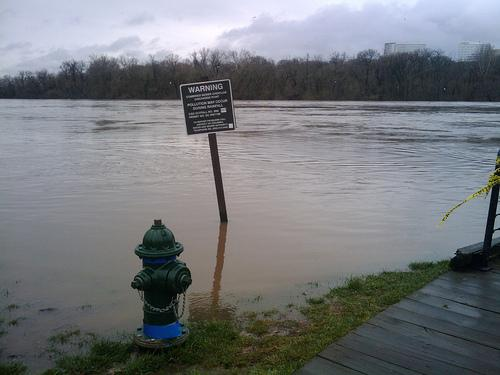Question: when was the photo taken?
Choices:
A. At night.
B. At dawn.
C. Daytime.
D. At dusk.
Answer with the letter. Answer: C Question: what color is the fire hydrant?
Choices:
A. Red and white.
B. Yellow and orange.
C. Silver and black.
D. Green and blue.
Answer with the letter. Answer: D Question: where is the fire hydrant?
Choices:
A. On the street.
B. Grass.
C. By the station.
D. By the house.
Answer with the letter. Answer: B Question: where was the photo taken?
Choices:
A. At a beach.
B. At a school.
C. Along a lake.
D. At an airport.
Answer with the letter. Answer: C Question: what is in the sky?
Choices:
A. Clouds.
B. The sun.
C. The moon.
D. Stars.
Answer with the letter. Answer: A 